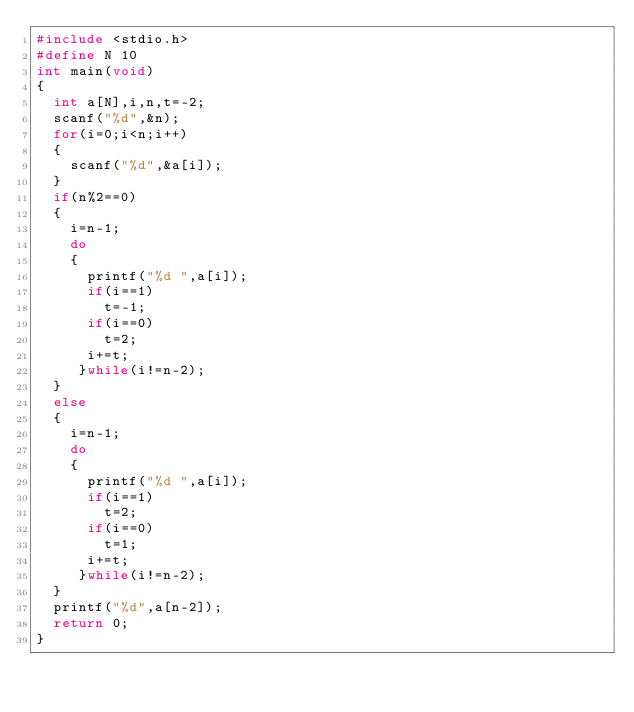Convert code to text. <code><loc_0><loc_0><loc_500><loc_500><_C_>#include <stdio.h>
#define N 10
int main(void)
{
	int a[N],i,n,t=-2;
	scanf("%d",&n);
	for(i=0;i<n;i++)
	{
		scanf("%d",&a[i]);
	}
	if(n%2==0)
	{
		i=n-1;
		do
		{
			printf("%d ",a[i]);
			if(i==1)
			  t=-1;
			if(i==0)
			  t=2;
			i+=t;
		 }while(i!=n-2);
	}
	else
	{
		i=n-1;
		do
		{
			printf("%d ",a[i]);
			if(i==1)
			  t=2;
			if(i==0)
			  t=1;
			i+=t;
		 }while(i!=n-2);
	}
	printf("%d",a[n-2]);
	return 0;
}</code> 